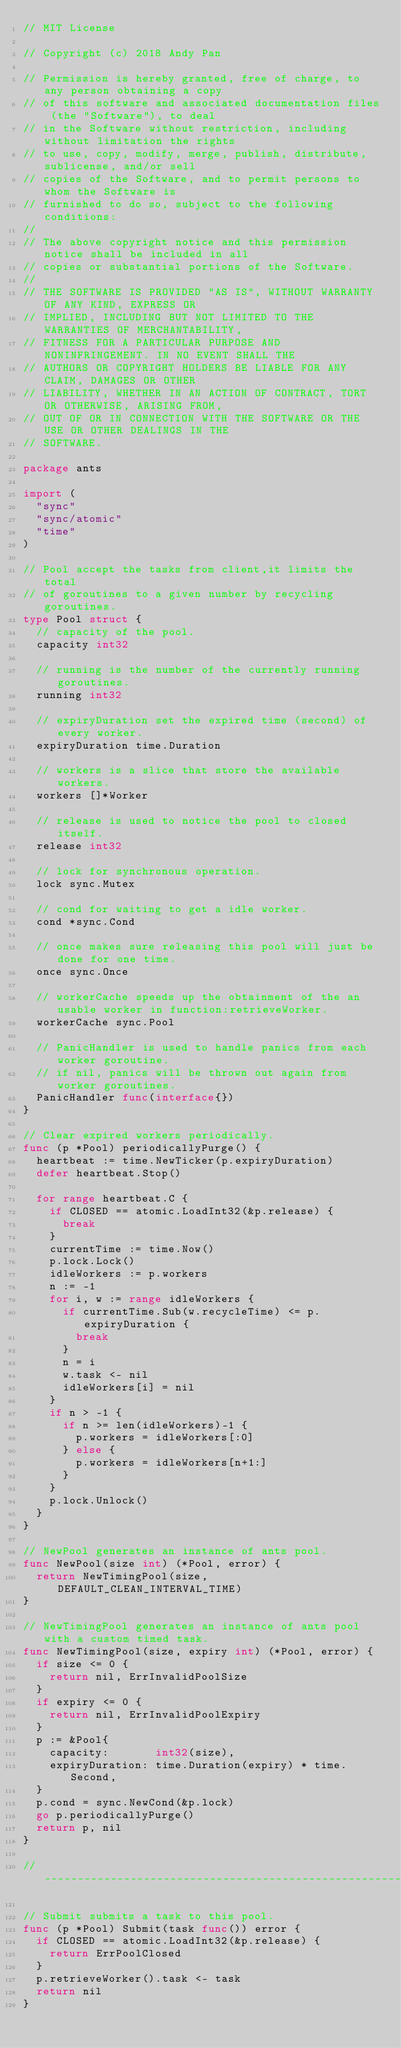Convert code to text. <code><loc_0><loc_0><loc_500><loc_500><_Go_>// MIT License

// Copyright (c) 2018 Andy Pan

// Permission is hereby granted, free of charge, to any person obtaining a copy
// of this software and associated documentation files (the "Software"), to deal
// in the Software without restriction, including without limitation the rights
// to use, copy, modify, merge, publish, distribute, sublicense, and/or sell
// copies of the Software, and to permit persons to whom the Software is
// furnished to do so, subject to the following conditions:
//
// The above copyright notice and this permission notice shall be included in all
// copies or substantial portions of the Software.
//
// THE SOFTWARE IS PROVIDED "AS IS", WITHOUT WARRANTY OF ANY KIND, EXPRESS OR
// IMPLIED, INCLUDING BUT NOT LIMITED TO THE WARRANTIES OF MERCHANTABILITY,
// FITNESS FOR A PARTICULAR PURPOSE AND NONINFRINGEMENT. IN NO EVENT SHALL THE
// AUTHORS OR COPYRIGHT HOLDERS BE LIABLE FOR ANY CLAIM, DAMAGES OR OTHER
// LIABILITY, WHETHER IN AN ACTION OF CONTRACT, TORT OR OTHERWISE, ARISING FROM,
// OUT OF OR IN CONNECTION WITH THE SOFTWARE OR THE USE OR OTHER DEALINGS IN THE
// SOFTWARE.

package ants

import (
	"sync"
	"sync/atomic"
	"time"
)

// Pool accept the tasks from client,it limits the total
// of goroutines to a given number by recycling goroutines.
type Pool struct {
	// capacity of the pool.
	capacity int32

	// running is the number of the currently running goroutines.
	running int32

	// expiryDuration set the expired time (second) of every worker.
	expiryDuration time.Duration

	// workers is a slice that store the available workers.
	workers []*Worker

	// release is used to notice the pool to closed itself.
	release int32

	// lock for synchronous operation.
	lock sync.Mutex

	// cond for waiting to get a idle worker.
	cond *sync.Cond

	// once makes sure releasing this pool will just be done for one time.
	once sync.Once

	// workerCache speeds up the obtainment of the an usable worker in function:retrieveWorker.
	workerCache sync.Pool

	// PanicHandler is used to handle panics from each worker goroutine.
	// if nil, panics will be thrown out again from worker goroutines.
	PanicHandler func(interface{})
}

// Clear expired workers periodically.
func (p *Pool) periodicallyPurge() {
	heartbeat := time.NewTicker(p.expiryDuration)
	defer heartbeat.Stop()

	for range heartbeat.C {
		if CLOSED == atomic.LoadInt32(&p.release) {
			break
		}
		currentTime := time.Now()
		p.lock.Lock()
		idleWorkers := p.workers
		n := -1
		for i, w := range idleWorkers {
			if currentTime.Sub(w.recycleTime) <= p.expiryDuration {
				break
			}
			n = i
			w.task <- nil
			idleWorkers[i] = nil
		}
		if n > -1 {
			if n >= len(idleWorkers)-1 {
				p.workers = idleWorkers[:0]
			} else {
				p.workers = idleWorkers[n+1:]
			}
		}
		p.lock.Unlock()
	}
}

// NewPool generates an instance of ants pool.
func NewPool(size int) (*Pool, error) {
	return NewTimingPool(size, DEFAULT_CLEAN_INTERVAL_TIME)
}

// NewTimingPool generates an instance of ants pool with a custom timed task.
func NewTimingPool(size, expiry int) (*Pool, error) {
	if size <= 0 {
		return nil, ErrInvalidPoolSize
	}
	if expiry <= 0 {
		return nil, ErrInvalidPoolExpiry
	}
	p := &Pool{
		capacity:       int32(size),
		expiryDuration: time.Duration(expiry) * time.Second,
	}
	p.cond = sync.NewCond(&p.lock)
	go p.periodicallyPurge()
	return p, nil
}

//---------------------------------------------------------------------------

// Submit submits a task to this pool.
func (p *Pool) Submit(task func()) error {
	if CLOSED == atomic.LoadInt32(&p.release) {
		return ErrPoolClosed
	}
	p.retrieveWorker().task <- task
	return nil
}
</code> 